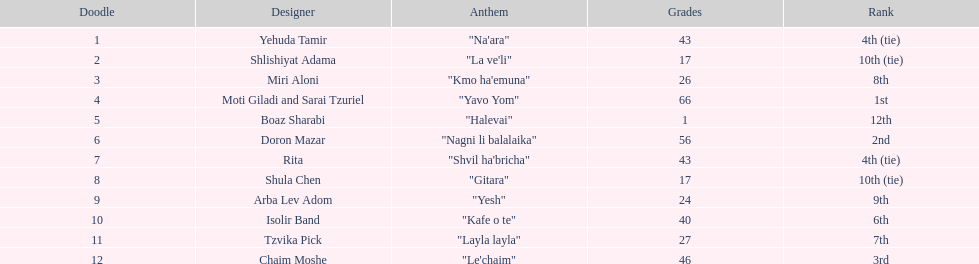What artist received the least amount of points in the competition? Boaz Sharabi. 